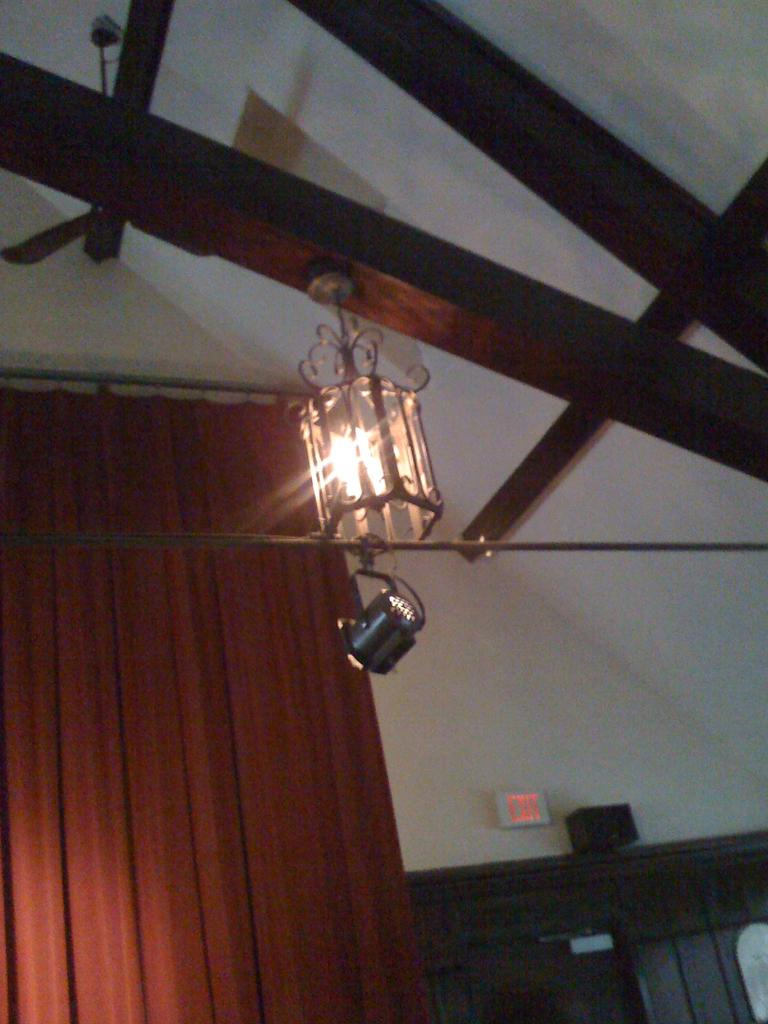What can be seen in the image that provides illumination? There are lights in the image. What type of structure is present in the image? There is a wall in the image. What type of window treatment is visible in the image? There is a curtain in the image. What covers the top of the structure in the image? There is a roof in the image. What type of material is used for some objects in the image? There are wooden sticks in the image. Can you describe the objects present in the image? There are some objects in the image, but their specific nature is not mentioned in the provided facts. How many cows are visible in the image? There are no cows present in the image. What type of wax is used to create the objects in the image? There is no mention of wax or any objects being created in the image. 